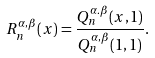Convert formula to latex. <formula><loc_0><loc_0><loc_500><loc_500>R _ { n } ^ { \alpha , \beta } ( x ) = \frac { Q _ { n } ^ { \alpha . \beta } ( x , 1 ) } { Q _ { n } ^ { \alpha , \beta } ( 1 , 1 ) } .</formula> 